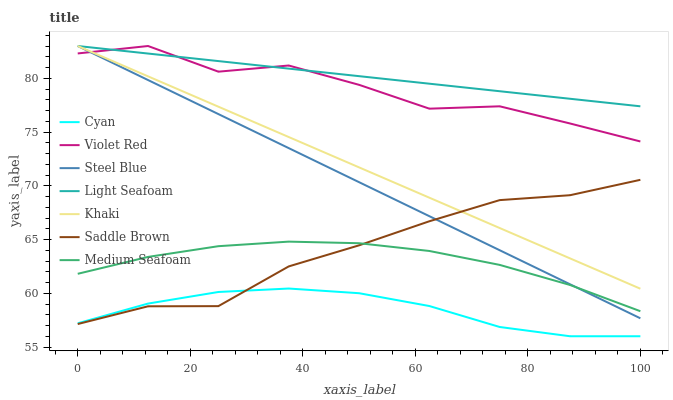Does Cyan have the minimum area under the curve?
Answer yes or no. Yes. Does Light Seafoam have the maximum area under the curve?
Answer yes or no. Yes. Does Khaki have the minimum area under the curve?
Answer yes or no. No. Does Khaki have the maximum area under the curve?
Answer yes or no. No. Is Steel Blue the smoothest?
Answer yes or no. Yes. Is Violet Red the roughest?
Answer yes or no. Yes. Is Khaki the smoothest?
Answer yes or no. No. Is Khaki the roughest?
Answer yes or no. No. Does Cyan have the lowest value?
Answer yes or no. Yes. Does Khaki have the lowest value?
Answer yes or no. No. Does Light Seafoam have the highest value?
Answer yes or no. Yes. Does Medium Seafoam have the highest value?
Answer yes or no. No. Is Cyan less than Medium Seafoam?
Answer yes or no. Yes. Is Khaki greater than Cyan?
Answer yes or no. Yes. Does Khaki intersect Saddle Brown?
Answer yes or no. Yes. Is Khaki less than Saddle Brown?
Answer yes or no. No. Is Khaki greater than Saddle Brown?
Answer yes or no. No. Does Cyan intersect Medium Seafoam?
Answer yes or no. No. 